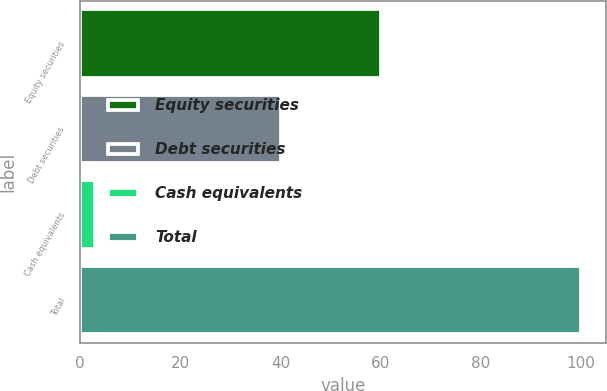Convert chart to OTSL. <chart><loc_0><loc_0><loc_500><loc_500><bar_chart><fcel>Equity securities<fcel>Debt securities<fcel>Cash equivalents<fcel>Total<nl><fcel>60<fcel>40<fcel>2.98<fcel>100<nl></chart> 